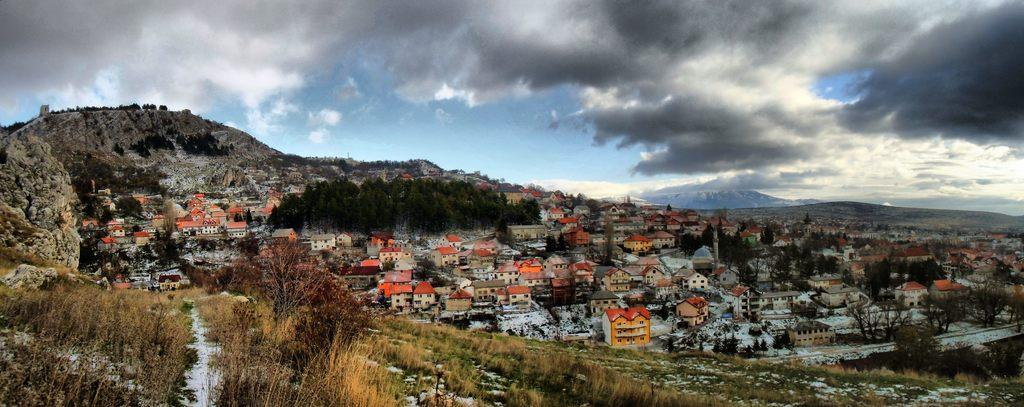What type of natural elements can be seen in the image? There are many trees and plants in the image. What type of geographical features are visible in the image? There are hills visible in the image. What is the condition of the sky in the image? The sky is cloudy and blue in the image. What type of man-made structures can be seen in the image? There are many buildings and houses in the image. Where is the grandmother running in the image? There is no grandmother or running depicted in the image. 